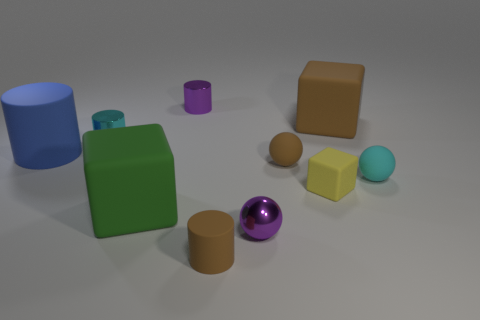Subtract all purple balls. How many balls are left? 2 Subtract 1 cylinders. How many cylinders are left? 3 Subtract all purple spheres. How many spheres are left? 2 Subtract all red cubes. Subtract all green cylinders. How many cubes are left? 3 Subtract all cylinders. How many objects are left? 6 Add 6 red cylinders. How many red cylinders exist? 6 Subtract 1 cyan cylinders. How many objects are left? 9 Subtract all tiny spheres. Subtract all tiny metallic cylinders. How many objects are left? 5 Add 2 small cyan matte spheres. How many small cyan matte spheres are left? 3 